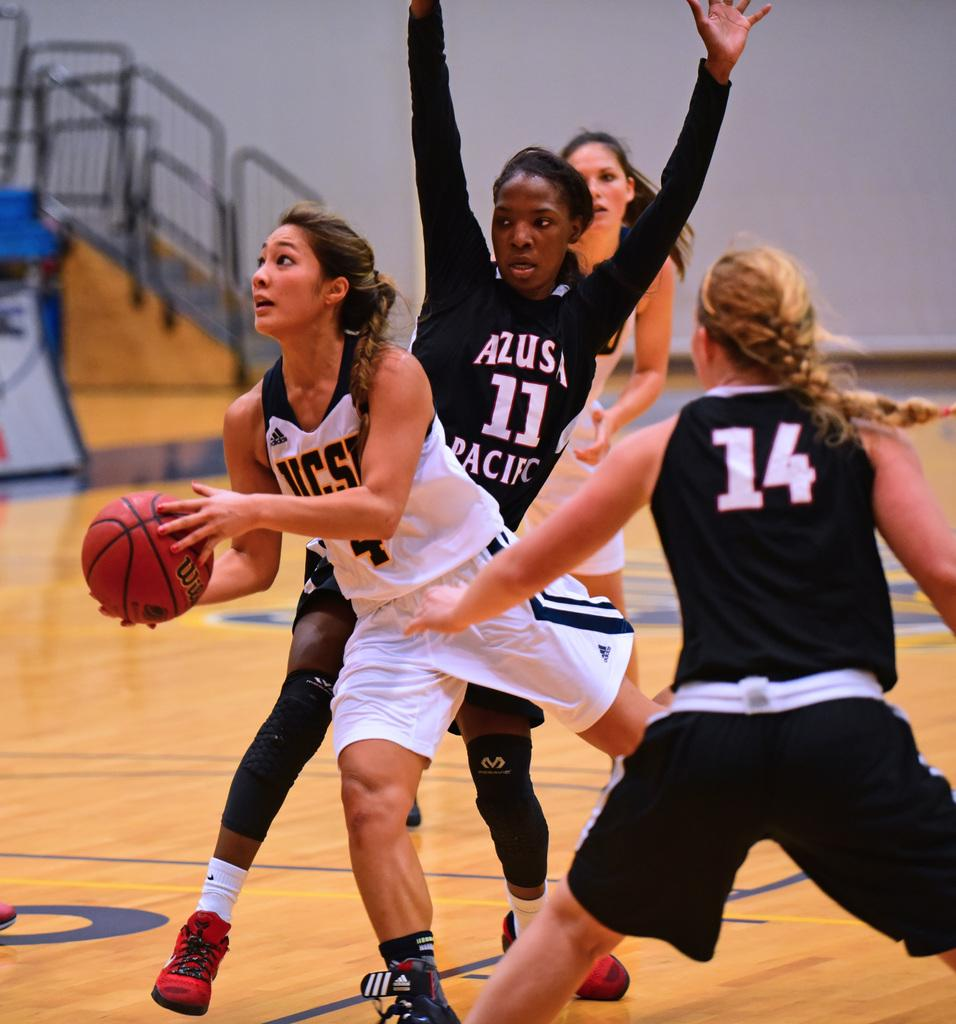<image>
Share a concise interpretation of the image provided. The girl with the ball in her hands wears number 4 